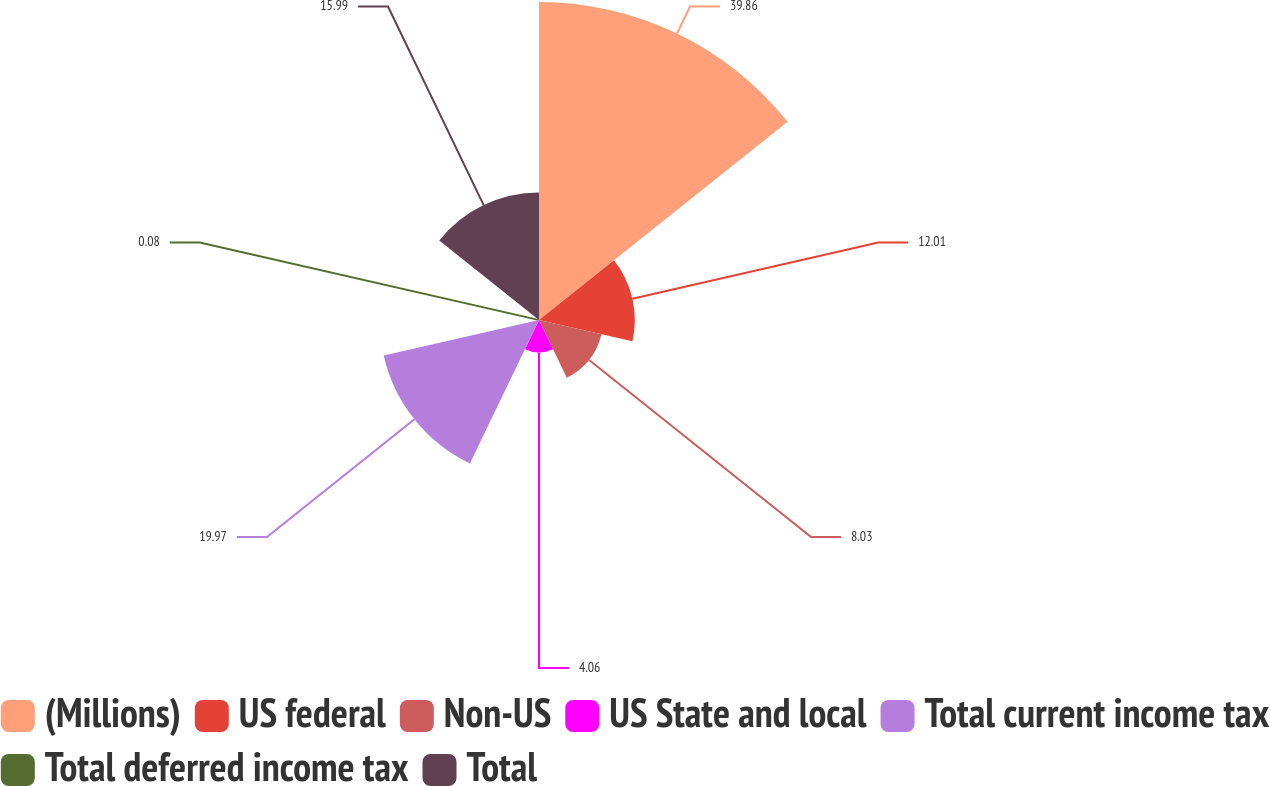Convert chart to OTSL. <chart><loc_0><loc_0><loc_500><loc_500><pie_chart><fcel>(Millions)<fcel>US federal<fcel>Non-US<fcel>US State and local<fcel>Total current income tax<fcel>Total deferred income tax<fcel>Total<nl><fcel>39.86%<fcel>12.01%<fcel>8.03%<fcel>4.06%<fcel>19.97%<fcel>0.08%<fcel>15.99%<nl></chart> 